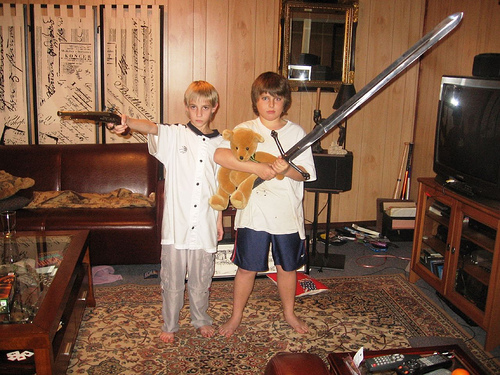Can you describe the room? The room has a cozy and lived-in feel, with wood-paneled walls adorned by a series of decorative objects. It's furnished with a brown sofa, a glass-top coffee table, and a patterned rug. There's a television set on a media cabinet and various items scattered around the room, giving it a personalized touch. 